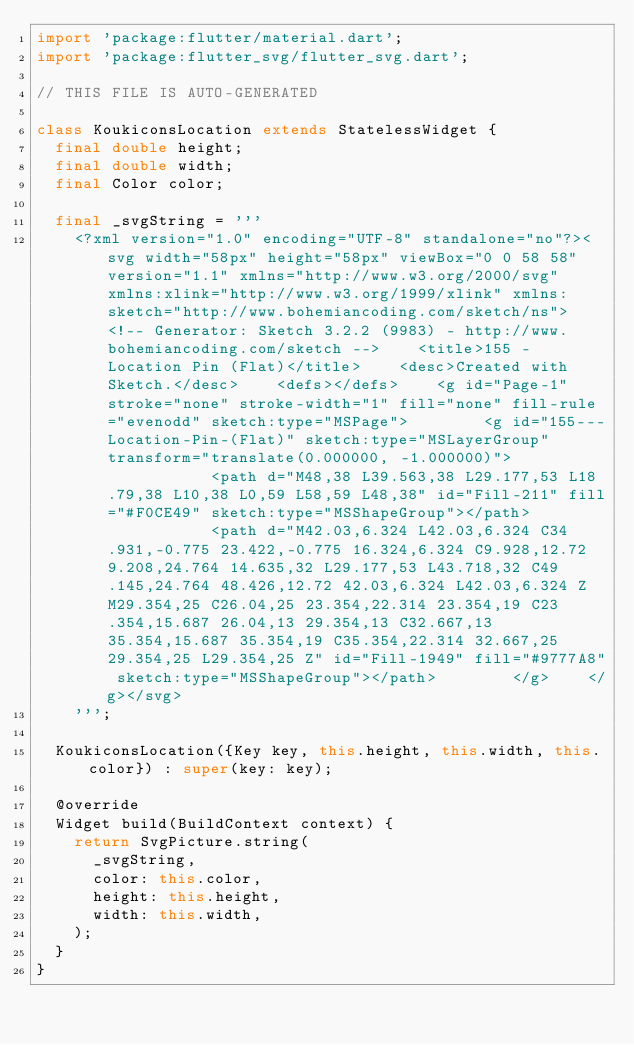<code> <loc_0><loc_0><loc_500><loc_500><_Dart_>import 'package:flutter/material.dart';
import 'package:flutter_svg/flutter_svg.dart';

// THIS FILE IS AUTO-GENERATED 

class KoukiconsLocation extends StatelessWidget {
  final double height;
  final double width;
  final Color color;

  final _svgString = '''
	<?xml version="1.0" encoding="UTF-8" standalone="no"?><svg width="58px" height="58px" viewBox="0 0 58 58" version="1.1" xmlns="http://www.w3.org/2000/svg" xmlns:xlink="http://www.w3.org/1999/xlink" xmlns:sketch="http://www.bohemiancoding.com/sketch/ns">    <!-- Generator: Sketch 3.2.2 (9983) - http://www.bohemiancoding.com/sketch -->    <title>155 - Location Pin (Flat)</title>    <desc>Created with Sketch.</desc>    <defs></defs>    <g id="Page-1" stroke="none" stroke-width="1" fill="none" fill-rule="evenodd" sketch:type="MSPage">        <g id="155---Location-Pin-(Flat)" sketch:type="MSLayerGroup" transform="translate(0.000000, -1.000000)">            <path d="M48,38 L39.563,38 L29.177,53 L18.79,38 L10,38 L0,59 L58,59 L48,38" id="Fill-211" fill="#F0CE49" sketch:type="MSShapeGroup"></path>            <path d="M42.03,6.324 L42.03,6.324 C34.931,-0.775 23.422,-0.775 16.324,6.324 C9.928,12.72 9.208,24.764 14.635,32 L29.177,53 L43.718,32 C49.145,24.764 48.426,12.72 42.03,6.324 L42.03,6.324 Z M29.354,25 C26.04,25 23.354,22.314 23.354,19 C23.354,15.687 26.04,13 29.354,13 C32.667,13 35.354,15.687 35.354,19 C35.354,22.314 32.667,25 29.354,25 L29.354,25 Z" id="Fill-1949" fill="#9777A8" sketch:type="MSShapeGroup"></path>        </g>    </g></svg>
    ''';

  KoukiconsLocation({Key key, this.height, this.width, this.color}) : super(key: key);

  @override
  Widget build(BuildContext context) {
    return SvgPicture.string(
      _svgString,
      color: this.color,
      height: this.height,
      width: this.width,
    );
  }
}

    </code> 